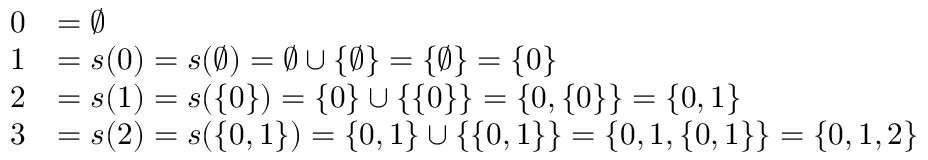Convert formula to latex. <formula><loc_0><loc_0><loc_500><loc_500>{ \begin{array} { r l } { 0 } & { = \emptyset } \\ { 1 } & { = s ( 0 ) = s ( \emptyset ) = \emptyset \cup \{ \emptyset \} = \{ \emptyset \} = \{ 0 \} } \\ { 2 } & { = s ( 1 ) = s ( \{ 0 \} ) = \{ 0 \} \cup \{ \{ 0 \} \} = \{ 0 , \{ 0 \} \} = \{ 0 , 1 \} } \\ { 3 } & { = s ( 2 ) = s ( \{ 0 , 1 \} ) = \{ 0 , 1 \} \cup \{ \{ 0 , 1 \} \} = \{ 0 , 1 , \{ 0 , 1 \} \} = \{ 0 , 1 , 2 \} } \end{array} }</formula> 